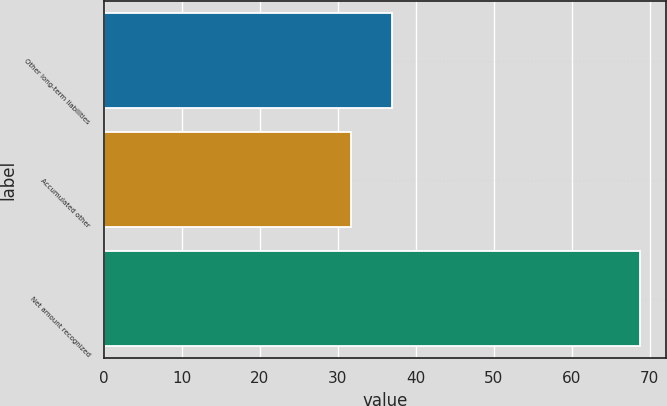Convert chart to OTSL. <chart><loc_0><loc_0><loc_500><loc_500><bar_chart><fcel>Other long-term liabilities<fcel>Accumulated other<fcel>Net amount recognized<nl><fcel>37<fcel>31.7<fcel>68.7<nl></chart> 